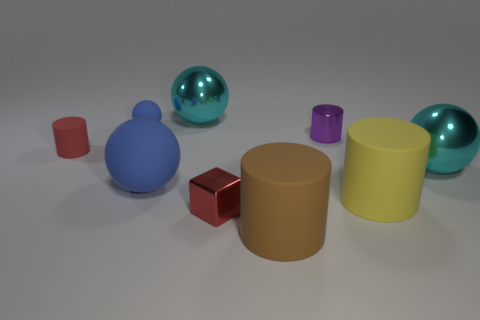Subtract all small rubber cylinders. How many cylinders are left? 3 Add 1 yellow matte objects. How many objects exist? 10 Add 1 large brown spheres. How many large brown spheres exist? 1 Subtract all blue spheres. How many spheres are left? 2 Subtract 2 blue balls. How many objects are left? 7 Subtract all cylinders. How many objects are left? 5 Subtract 2 cylinders. How many cylinders are left? 2 Subtract all green cylinders. Subtract all brown cubes. How many cylinders are left? 4 Subtract all blue cubes. How many blue spheres are left? 2 Subtract all tiny red rubber things. Subtract all small red things. How many objects are left? 6 